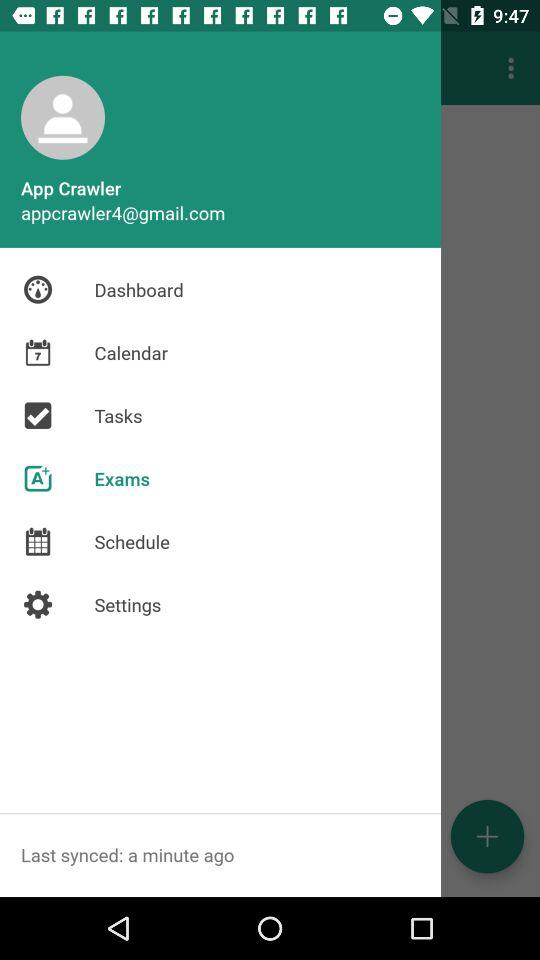When was it last synced? It was last synced a minute ago. 